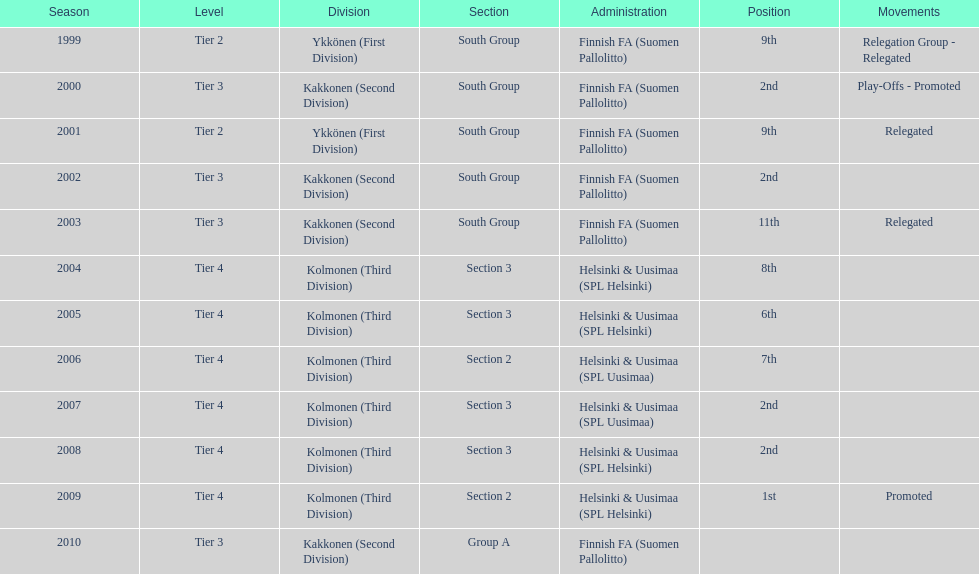Which administration has the minimal amount of separation? Helsinki & Uusimaa (SPL Helsinki). 